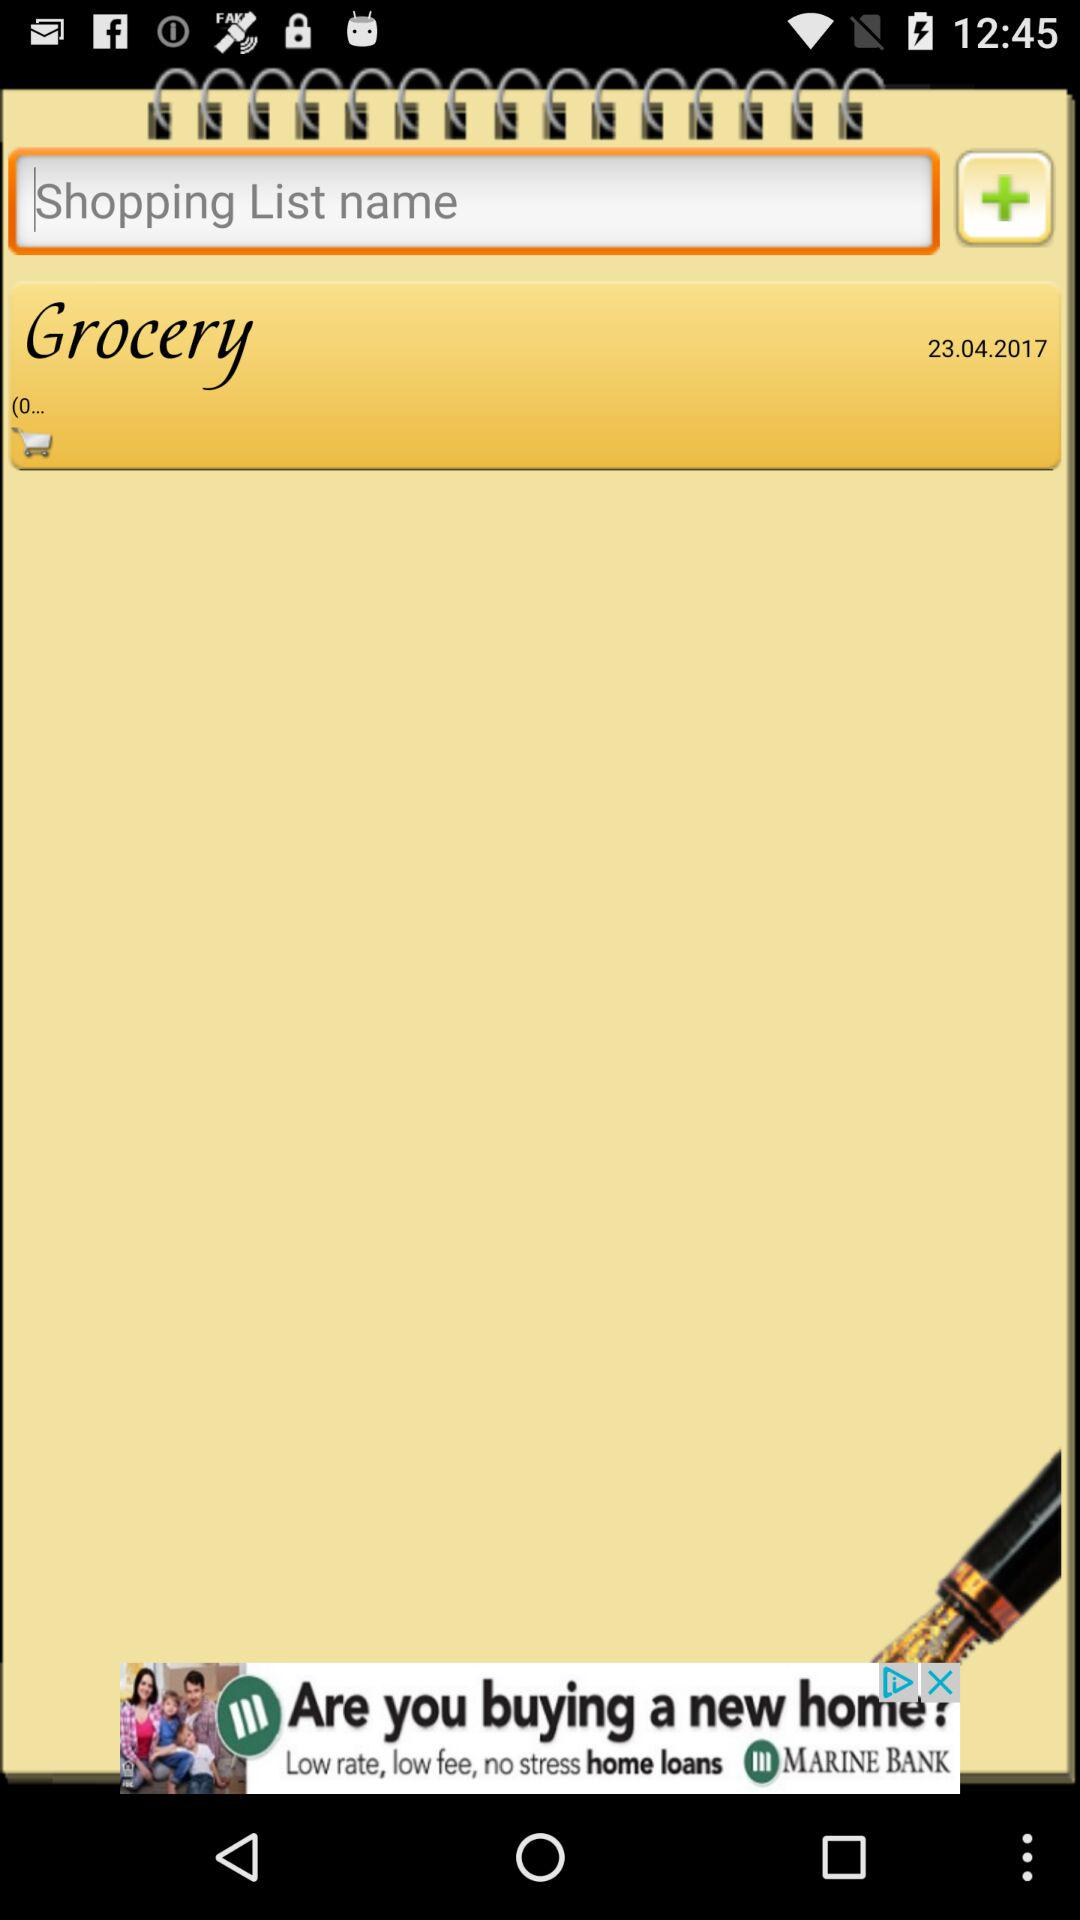When was the "Grocery" taken? The "Grocery" was taken on April 23, 2017. 